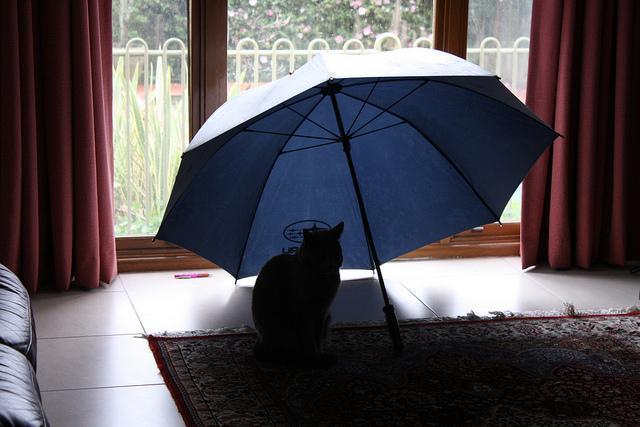How many buses are there?
Give a very brief answer. 0. 